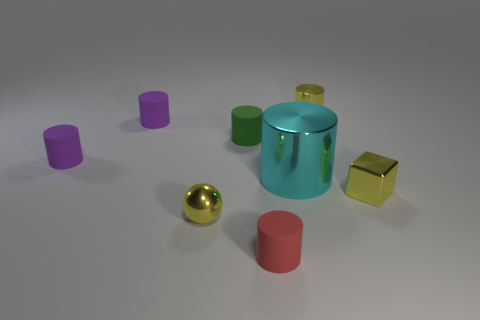What number of small metallic cylinders are the same color as the block?
Provide a succinct answer. 1. What number of rubber objects are in front of the green rubber object and behind the small shiny block?
Your answer should be compact. 1. How many other objects are the same size as the red matte thing?
Your answer should be compact. 6. What is the material of the object that is left of the tiny red matte object and to the right of the yellow sphere?
Your answer should be very brief. Rubber. Does the tiny block have the same color as the cylinder that is in front of the tiny yellow cube?
Give a very brief answer. No. What size is the red matte object that is the same shape as the big cyan metallic thing?
Offer a very short reply. Small. The tiny object that is both on the right side of the large cyan shiny cylinder and behind the big cyan object has what shape?
Your answer should be very brief. Cylinder. Does the metal sphere have the same size as the metallic object behind the big cyan object?
Offer a very short reply. Yes. The big shiny thing that is the same shape as the small green rubber object is what color?
Provide a succinct answer. Cyan. Do the rubber cylinder in front of the tiny metal cube and the metal cylinder that is on the left side of the tiny yellow metal cylinder have the same size?
Give a very brief answer. No. 